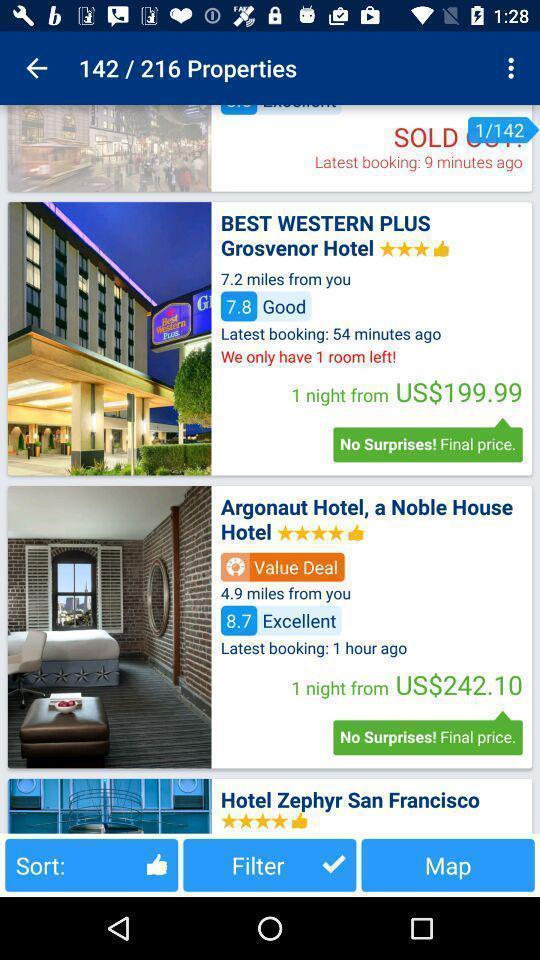Describe the content in this image. Screen displaying hotels. 